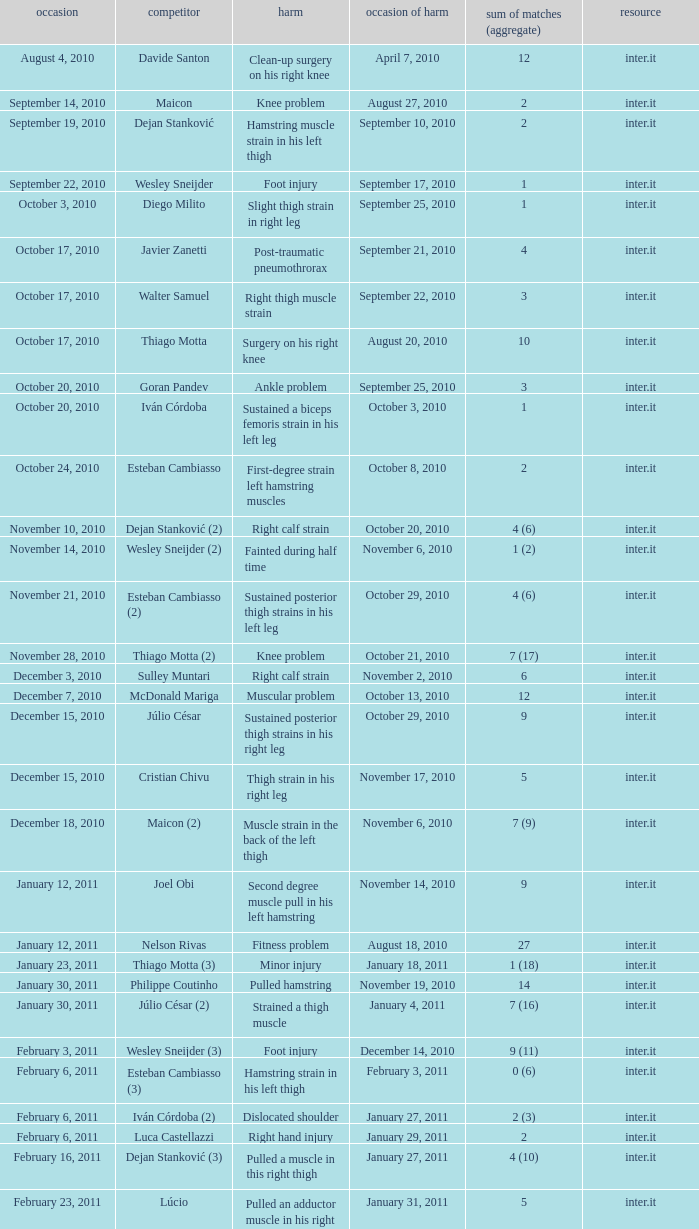What is the date of injury for player Wesley sneijder (2)? November 6, 2010. 